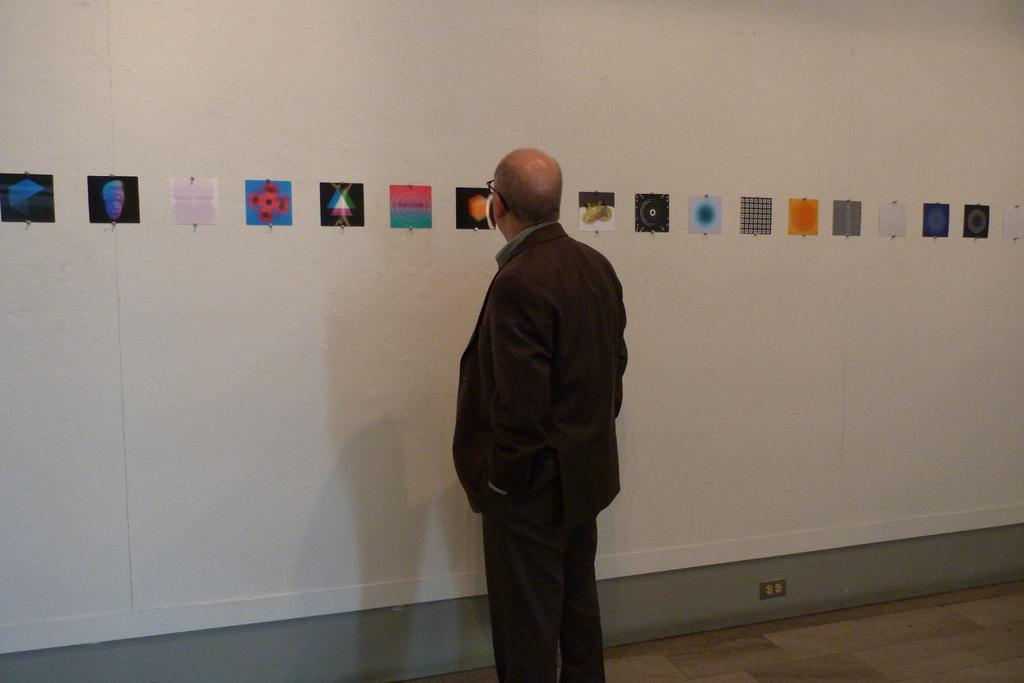What is the person in the image wearing? The person is wearing a suit in the image. Where is the person located in the image? The person is in the center of the image. What is in front of the person? There is a wall in front of the person. What color is the wall? The wall is painted white. What is attached to the wall? There are posters attached to the wall. How many babies are crawling on the wall in the image? There are no babies present in the image; the wall is painted white and has posters attached to it. 